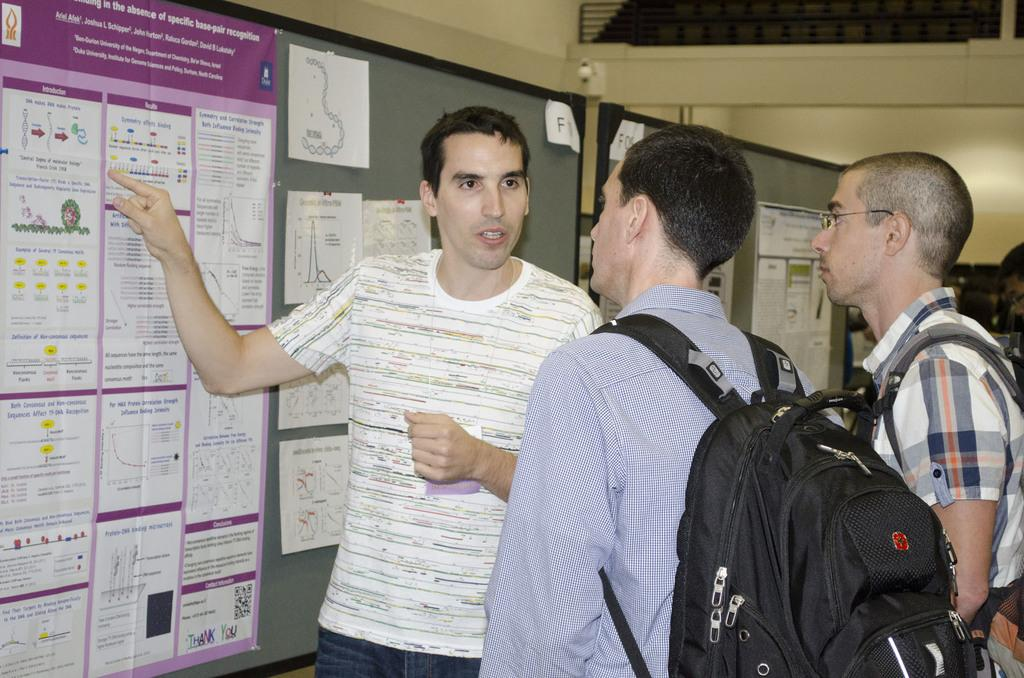<image>
Offer a succinct explanation of the picture presented. the word absence sits at the top of a purple sign with students next to it 